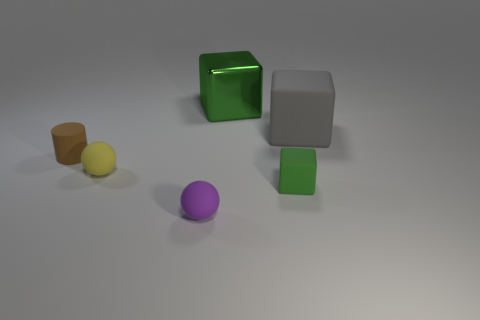Subtract all tiny blocks. How many blocks are left? 2 Subtract all gray cubes. How many cubes are left? 2 Subtract all cylinders. How many objects are left? 5 Add 1 green cylinders. How many objects exist? 7 Subtract all red balls. Subtract all blue cubes. How many balls are left? 2 Subtract all brown cubes. How many yellow balls are left? 1 Subtract all matte things. Subtract all gray matte objects. How many objects are left? 0 Add 5 purple objects. How many purple objects are left? 6 Add 2 tiny brown objects. How many tiny brown objects exist? 3 Subtract 0 cyan spheres. How many objects are left? 6 